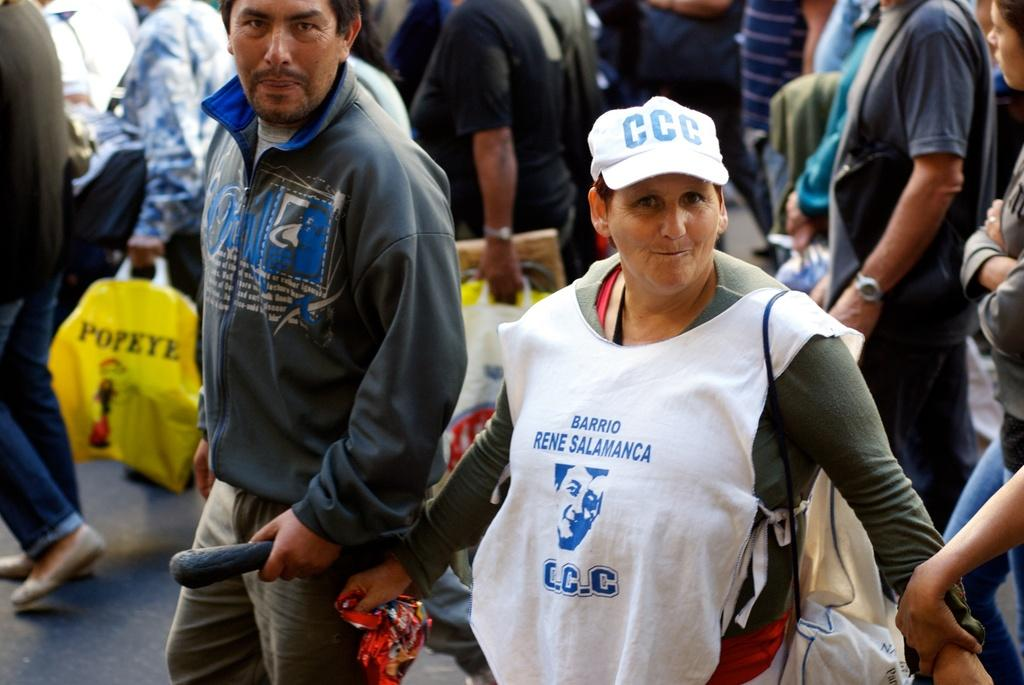What is happening on the road in the image? There is a group of people on the road in the image. What are some of the people holding? Some people are holding bags in the image. Can you describe the woman's attire in the image? One woman is wearing a bag in the image. In which direction are the people walking in the image? The image does not show the people walking, so it is not possible to determine their direction. 